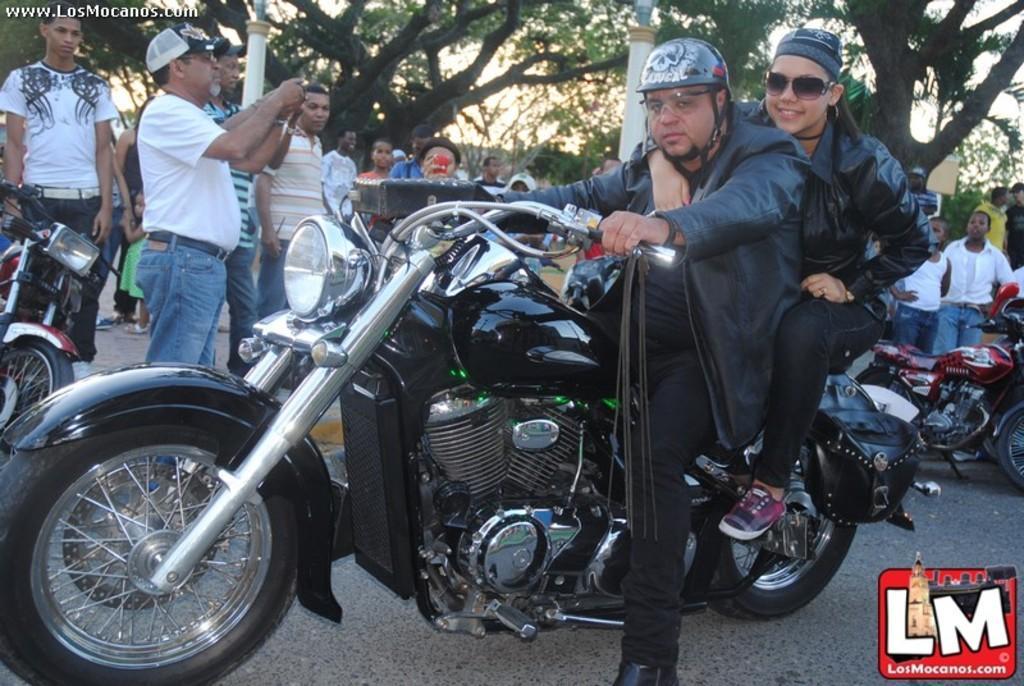Can you describe this image briefly? Here we can see a couple of people sitting on a bike and behind them we can see motorbikes and people standing and there are trees behind them 